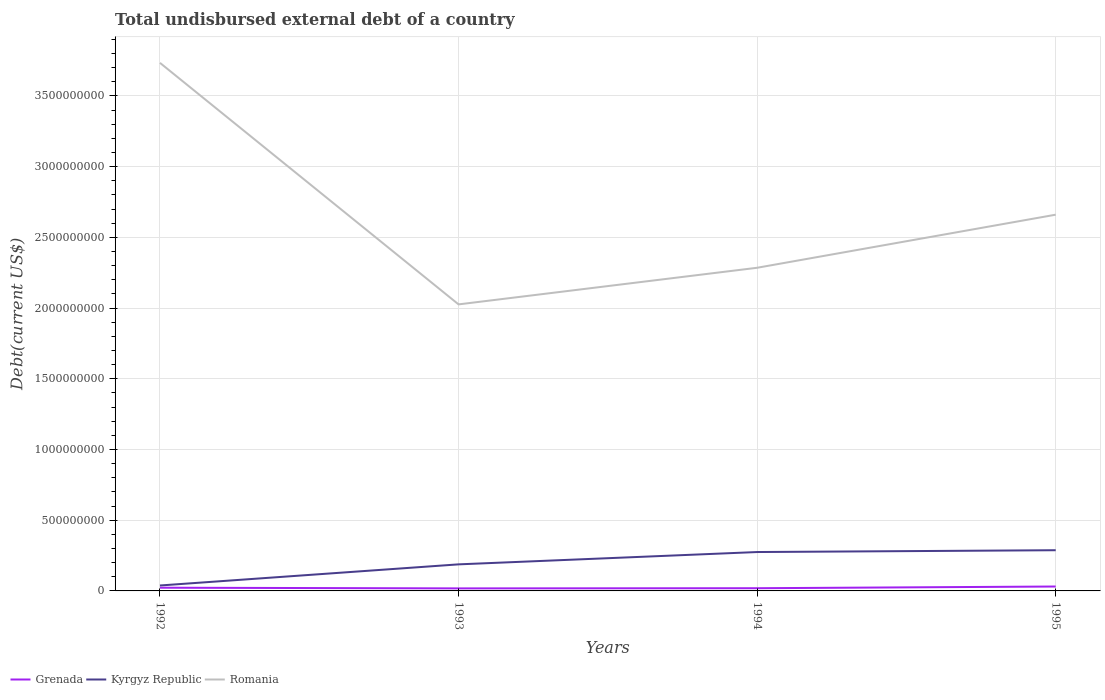How many different coloured lines are there?
Make the answer very short. 3. Across all years, what is the maximum total undisbursed external debt in Kyrgyz Republic?
Ensure brevity in your answer.  3.84e+07. What is the total total undisbursed external debt in Kyrgyz Republic in the graph?
Your answer should be very brief. -8.71e+07. What is the difference between the highest and the second highest total undisbursed external debt in Grenada?
Your answer should be compact. 1.32e+07. How many lines are there?
Offer a terse response. 3. Does the graph contain grids?
Provide a succinct answer. Yes. Where does the legend appear in the graph?
Your answer should be compact. Bottom left. What is the title of the graph?
Offer a very short reply. Total undisbursed external debt of a country. Does "Hungary" appear as one of the legend labels in the graph?
Offer a terse response. No. What is the label or title of the Y-axis?
Provide a short and direct response. Debt(current US$). What is the Debt(current US$) in Grenada in 1992?
Ensure brevity in your answer.  2.28e+07. What is the Debt(current US$) of Kyrgyz Republic in 1992?
Ensure brevity in your answer.  3.84e+07. What is the Debt(current US$) in Romania in 1992?
Offer a terse response. 3.73e+09. What is the Debt(current US$) in Grenada in 1993?
Your answer should be compact. 1.79e+07. What is the Debt(current US$) of Kyrgyz Republic in 1993?
Give a very brief answer. 1.88e+08. What is the Debt(current US$) of Romania in 1993?
Provide a succinct answer. 2.03e+09. What is the Debt(current US$) of Grenada in 1994?
Make the answer very short. 1.91e+07. What is the Debt(current US$) in Kyrgyz Republic in 1994?
Provide a short and direct response. 2.75e+08. What is the Debt(current US$) in Romania in 1994?
Offer a very short reply. 2.28e+09. What is the Debt(current US$) of Grenada in 1995?
Provide a succinct answer. 3.11e+07. What is the Debt(current US$) of Kyrgyz Republic in 1995?
Make the answer very short. 2.88e+08. What is the Debt(current US$) of Romania in 1995?
Provide a short and direct response. 2.66e+09. Across all years, what is the maximum Debt(current US$) of Grenada?
Provide a succinct answer. 3.11e+07. Across all years, what is the maximum Debt(current US$) in Kyrgyz Republic?
Offer a terse response. 2.88e+08. Across all years, what is the maximum Debt(current US$) in Romania?
Provide a short and direct response. 3.73e+09. Across all years, what is the minimum Debt(current US$) in Grenada?
Ensure brevity in your answer.  1.79e+07. Across all years, what is the minimum Debt(current US$) in Kyrgyz Republic?
Give a very brief answer. 3.84e+07. Across all years, what is the minimum Debt(current US$) of Romania?
Your response must be concise. 2.03e+09. What is the total Debt(current US$) of Grenada in the graph?
Offer a terse response. 9.10e+07. What is the total Debt(current US$) in Kyrgyz Republic in the graph?
Provide a short and direct response. 7.89e+08. What is the total Debt(current US$) of Romania in the graph?
Offer a terse response. 1.07e+1. What is the difference between the Debt(current US$) in Grenada in 1992 and that in 1993?
Keep it short and to the point. 4.84e+06. What is the difference between the Debt(current US$) of Kyrgyz Republic in 1992 and that in 1993?
Offer a terse response. -1.49e+08. What is the difference between the Debt(current US$) of Romania in 1992 and that in 1993?
Your answer should be compact. 1.71e+09. What is the difference between the Debt(current US$) of Grenada in 1992 and that in 1994?
Your answer should be compact. 3.63e+06. What is the difference between the Debt(current US$) of Kyrgyz Republic in 1992 and that in 1994?
Offer a terse response. -2.37e+08. What is the difference between the Debt(current US$) in Romania in 1992 and that in 1994?
Your response must be concise. 1.45e+09. What is the difference between the Debt(current US$) of Grenada in 1992 and that in 1995?
Offer a terse response. -8.35e+06. What is the difference between the Debt(current US$) in Kyrgyz Republic in 1992 and that in 1995?
Ensure brevity in your answer.  -2.49e+08. What is the difference between the Debt(current US$) of Romania in 1992 and that in 1995?
Provide a succinct answer. 1.07e+09. What is the difference between the Debt(current US$) in Grenada in 1993 and that in 1994?
Offer a terse response. -1.21e+06. What is the difference between the Debt(current US$) of Kyrgyz Republic in 1993 and that in 1994?
Keep it short and to the point. -8.71e+07. What is the difference between the Debt(current US$) of Romania in 1993 and that in 1994?
Offer a terse response. -2.59e+08. What is the difference between the Debt(current US$) in Grenada in 1993 and that in 1995?
Your answer should be very brief. -1.32e+07. What is the difference between the Debt(current US$) in Kyrgyz Republic in 1993 and that in 1995?
Your answer should be compact. -9.99e+07. What is the difference between the Debt(current US$) in Romania in 1993 and that in 1995?
Provide a succinct answer. -6.34e+08. What is the difference between the Debt(current US$) of Grenada in 1994 and that in 1995?
Ensure brevity in your answer.  -1.20e+07. What is the difference between the Debt(current US$) of Kyrgyz Republic in 1994 and that in 1995?
Give a very brief answer. -1.28e+07. What is the difference between the Debt(current US$) in Romania in 1994 and that in 1995?
Make the answer very short. -3.75e+08. What is the difference between the Debt(current US$) of Grenada in 1992 and the Debt(current US$) of Kyrgyz Republic in 1993?
Give a very brief answer. -1.65e+08. What is the difference between the Debt(current US$) in Grenada in 1992 and the Debt(current US$) in Romania in 1993?
Offer a terse response. -2.00e+09. What is the difference between the Debt(current US$) in Kyrgyz Republic in 1992 and the Debt(current US$) in Romania in 1993?
Your answer should be very brief. -1.99e+09. What is the difference between the Debt(current US$) in Grenada in 1992 and the Debt(current US$) in Kyrgyz Republic in 1994?
Make the answer very short. -2.52e+08. What is the difference between the Debt(current US$) in Grenada in 1992 and the Debt(current US$) in Romania in 1994?
Offer a terse response. -2.26e+09. What is the difference between the Debt(current US$) in Kyrgyz Republic in 1992 and the Debt(current US$) in Romania in 1994?
Your response must be concise. -2.25e+09. What is the difference between the Debt(current US$) in Grenada in 1992 and the Debt(current US$) in Kyrgyz Republic in 1995?
Your answer should be compact. -2.65e+08. What is the difference between the Debt(current US$) in Grenada in 1992 and the Debt(current US$) in Romania in 1995?
Provide a succinct answer. -2.64e+09. What is the difference between the Debt(current US$) of Kyrgyz Republic in 1992 and the Debt(current US$) of Romania in 1995?
Provide a succinct answer. -2.62e+09. What is the difference between the Debt(current US$) of Grenada in 1993 and the Debt(current US$) of Kyrgyz Republic in 1994?
Your answer should be compact. -2.57e+08. What is the difference between the Debt(current US$) in Grenada in 1993 and the Debt(current US$) in Romania in 1994?
Provide a succinct answer. -2.27e+09. What is the difference between the Debt(current US$) of Kyrgyz Republic in 1993 and the Debt(current US$) of Romania in 1994?
Your response must be concise. -2.10e+09. What is the difference between the Debt(current US$) in Grenada in 1993 and the Debt(current US$) in Kyrgyz Republic in 1995?
Give a very brief answer. -2.70e+08. What is the difference between the Debt(current US$) of Grenada in 1993 and the Debt(current US$) of Romania in 1995?
Your answer should be compact. -2.64e+09. What is the difference between the Debt(current US$) of Kyrgyz Republic in 1993 and the Debt(current US$) of Romania in 1995?
Your answer should be very brief. -2.47e+09. What is the difference between the Debt(current US$) in Grenada in 1994 and the Debt(current US$) in Kyrgyz Republic in 1995?
Offer a very short reply. -2.69e+08. What is the difference between the Debt(current US$) of Grenada in 1994 and the Debt(current US$) of Romania in 1995?
Offer a very short reply. -2.64e+09. What is the difference between the Debt(current US$) of Kyrgyz Republic in 1994 and the Debt(current US$) of Romania in 1995?
Provide a succinct answer. -2.39e+09. What is the average Debt(current US$) of Grenada per year?
Provide a succinct answer. 2.27e+07. What is the average Debt(current US$) of Kyrgyz Republic per year?
Offer a terse response. 1.97e+08. What is the average Debt(current US$) in Romania per year?
Your response must be concise. 2.68e+09. In the year 1992, what is the difference between the Debt(current US$) of Grenada and Debt(current US$) of Kyrgyz Republic?
Make the answer very short. -1.57e+07. In the year 1992, what is the difference between the Debt(current US$) in Grenada and Debt(current US$) in Romania?
Your response must be concise. -3.71e+09. In the year 1992, what is the difference between the Debt(current US$) of Kyrgyz Republic and Debt(current US$) of Romania?
Offer a terse response. -3.70e+09. In the year 1993, what is the difference between the Debt(current US$) of Grenada and Debt(current US$) of Kyrgyz Republic?
Keep it short and to the point. -1.70e+08. In the year 1993, what is the difference between the Debt(current US$) of Grenada and Debt(current US$) of Romania?
Keep it short and to the point. -2.01e+09. In the year 1993, what is the difference between the Debt(current US$) of Kyrgyz Republic and Debt(current US$) of Romania?
Your answer should be compact. -1.84e+09. In the year 1994, what is the difference between the Debt(current US$) of Grenada and Debt(current US$) of Kyrgyz Republic?
Keep it short and to the point. -2.56e+08. In the year 1994, what is the difference between the Debt(current US$) in Grenada and Debt(current US$) in Romania?
Your answer should be very brief. -2.27e+09. In the year 1994, what is the difference between the Debt(current US$) in Kyrgyz Republic and Debt(current US$) in Romania?
Give a very brief answer. -2.01e+09. In the year 1995, what is the difference between the Debt(current US$) in Grenada and Debt(current US$) in Kyrgyz Republic?
Offer a terse response. -2.57e+08. In the year 1995, what is the difference between the Debt(current US$) of Grenada and Debt(current US$) of Romania?
Keep it short and to the point. -2.63e+09. In the year 1995, what is the difference between the Debt(current US$) of Kyrgyz Republic and Debt(current US$) of Romania?
Give a very brief answer. -2.37e+09. What is the ratio of the Debt(current US$) of Grenada in 1992 to that in 1993?
Provide a short and direct response. 1.27. What is the ratio of the Debt(current US$) of Kyrgyz Republic in 1992 to that in 1993?
Offer a very short reply. 0.2. What is the ratio of the Debt(current US$) in Romania in 1992 to that in 1993?
Give a very brief answer. 1.84. What is the ratio of the Debt(current US$) of Grenada in 1992 to that in 1994?
Your answer should be compact. 1.19. What is the ratio of the Debt(current US$) in Kyrgyz Republic in 1992 to that in 1994?
Offer a terse response. 0.14. What is the ratio of the Debt(current US$) of Romania in 1992 to that in 1994?
Offer a terse response. 1.63. What is the ratio of the Debt(current US$) of Grenada in 1992 to that in 1995?
Keep it short and to the point. 0.73. What is the ratio of the Debt(current US$) of Kyrgyz Republic in 1992 to that in 1995?
Your response must be concise. 0.13. What is the ratio of the Debt(current US$) in Romania in 1992 to that in 1995?
Your answer should be compact. 1.4. What is the ratio of the Debt(current US$) in Grenada in 1993 to that in 1994?
Your response must be concise. 0.94. What is the ratio of the Debt(current US$) of Kyrgyz Republic in 1993 to that in 1994?
Provide a short and direct response. 0.68. What is the ratio of the Debt(current US$) of Romania in 1993 to that in 1994?
Offer a terse response. 0.89. What is the ratio of the Debt(current US$) of Grenada in 1993 to that in 1995?
Offer a very short reply. 0.58. What is the ratio of the Debt(current US$) of Kyrgyz Republic in 1993 to that in 1995?
Give a very brief answer. 0.65. What is the ratio of the Debt(current US$) in Romania in 1993 to that in 1995?
Offer a very short reply. 0.76. What is the ratio of the Debt(current US$) in Grenada in 1994 to that in 1995?
Your answer should be very brief. 0.62. What is the ratio of the Debt(current US$) in Kyrgyz Republic in 1994 to that in 1995?
Provide a short and direct response. 0.96. What is the ratio of the Debt(current US$) of Romania in 1994 to that in 1995?
Provide a succinct answer. 0.86. What is the difference between the highest and the second highest Debt(current US$) of Grenada?
Give a very brief answer. 8.35e+06. What is the difference between the highest and the second highest Debt(current US$) in Kyrgyz Republic?
Keep it short and to the point. 1.28e+07. What is the difference between the highest and the second highest Debt(current US$) of Romania?
Offer a very short reply. 1.07e+09. What is the difference between the highest and the lowest Debt(current US$) of Grenada?
Your response must be concise. 1.32e+07. What is the difference between the highest and the lowest Debt(current US$) of Kyrgyz Republic?
Offer a very short reply. 2.49e+08. What is the difference between the highest and the lowest Debt(current US$) of Romania?
Offer a very short reply. 1.71e+09. 